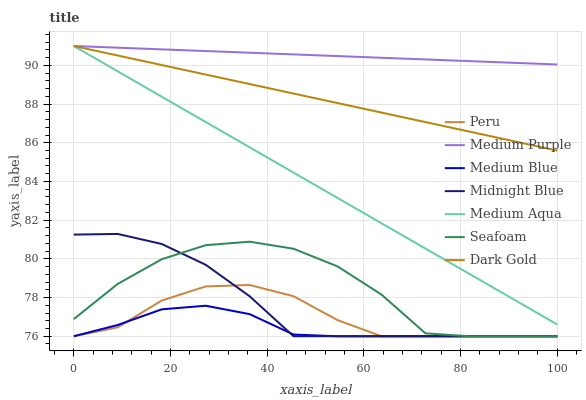Does Medium Blue have the minimum area under the curve?
Answer yes or no. Yes. Does Medium Purple have the maximum area under the curve?
Answer yes or no. Yes. Does Dark Gold have the minimum area under the curve?
Answer yes or no. No. Does Dark Gold have the maximum area under the curve?
Answer yes or no. No. Is Dark Gold the smoothest?
Answer yes or no. Yes. Is Seafoam the roughest?
Answer yes or no. Yes. Is Medium Blue the smoothest?
Answer yes or no. No. Is Medium Blue the roughest?
Answer yes or no. No. Does Midnight Blue have the lowest value?
Answer yes or no. Yes. Does Dark Gold have the lowest value?
Answer yes or no. No. Does Medium Aqua have the highest value?
Answer yes or no. Yes. Does Medium Blue have the highest value?
Answer yes or no. No. Is Medium Blue less than Medium Purple?
Answer yes or no. Yes. Is Medium Purple greater than Peru?
Answer yes or no. Yes. Does Medium Blue intersect Midnight Blue?
Answer yes or no. Yes. Is Medium Blue less than Midnight Blue?
Answer yes or no. No. Is Medium Blue greater than Midnight Blue?
Answer yes or no. No. Does Medium Blue intersect Medium Purple?
Answer yes or no. No. 